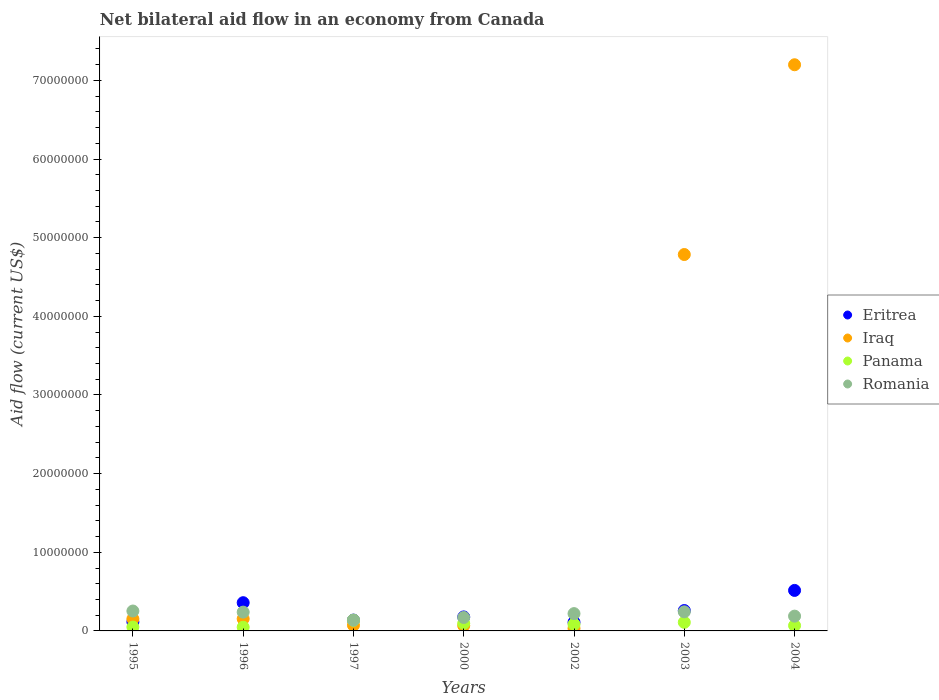What is the net bilateral aid flow in Romania in 1996?
Ensure brevity in your answer.  2.39e+06. Across all years, what is the maximum net bilateral aid flow in Eritrea?
Provide a short and direct response. 5.15e+06. In which year was the net bilateral aid flow in Eritrea minimum?
Keep it short and to the point. 2002. What is the total net bilateral aid flow in Eritrea in the graph?
Your response must be concise. 1.67e+07. What is the difference between the net bilateral aid flow in Eritrea in 2002 and that in 2003?
Give a very brief answer. -1.49e+06. What is the difference between the net bilateral aid flow in Panama in 2002 and the net bilateral aid flow in Iraq in 2003?
Your response must be concise. -4.70e+07. What is the average net bilateral aid flow in Romania per year?
Give a very brief answer. 2.07e+06. In the year 1995, what is the difference between the net bilateral aid flow in Eritrea and net bilateral aid flow in Romania?
Offer a terse response. -1.38e+06. In how many years, is the net bilateral aid flow in Iraq greater than 18000000 US$?
Make the answer very short. 2. What is the ratio of the net bilateral aid flow in Iraq in 2000 to that in 2004?
Your answer should be compact. 0.01. Is the net bilateral aid flow in Eritrea in 2002 less than that in 2003?
Give a very brief answer. Yes. Is the difference between the net bilateral aid flow in Eritrea in 1995 and 2000 greater than the difference between the net bilateral aid flow in Romania in 1995 and 2000?
Your response must be concise. No. What is the difference between the highest and the lowest net bilateral aid flow in Iraq?
Give a very brief answer. 7.17e+07. In how many years, is the net bilateral aid flow in Romania greater than the average net bilateral aid flow in Romania taken over all years?
Provide a succinct answer. 4. Is the sum of the net bilateral aid flow in Iraq in 1997 and 2004 greater than the maximum net bilateral aid flow in Romania across all years?
Offer a very short reply. Yes. Is it the case that in every year, the sum of the net bilateral aid flow in Romania and net bilateral aid flow in Panama  is greater than the sum of net bilateral aid flow in Iraq and net bilateral aid flow in Eritrea?
Give a very brief answer. No. Does the net bilateral aid flow in Romania monotonically increase over the years?
Give a very brief answer. No. How many dotlines are there?
Provide a short and direct response. 4. What is the difference between two consecutive major ticks on the Y-axis?
Ensure brevity in your answer.  1.00e+07. Are the values on the major ticks of Y-axis written in scientific E-notation?
Offer a terse response. No. Does the graph contain grids?
Give a very brief answer. No. Where does the legend appear in the graph?
Give a very brief answer. Center right. What is the title of the graph?
Offer a very short reply. Net bilateral aid flow in an economy from Canada. What is the label or title of the X-axis?
Ensure brevity in your answer.  Years. What is the label or title of the Y-axis?
Provide a succinct answer. Aid flow (current US$). What is the Aid flow (current US$) in Eritrea in 1995?
Your response must be concise. 1.15e+06. What is the Aid flow (current US$) in Iraq in 1995?
Provide a succinct answer. 1.53e+06. What is the Aid flow (current US$) in Romania in 1995?
Give a very brief answer. 2.53e+06. What is the Aid flow (current US$) in Eritrea in 1996?
Offer a terse response. 3.59e+06. What is the Aid flow (current US$) in Iraq in 1996?
Ensure brevity in your answer.  1.54e+06. What is the Aid flow (current US$) of Panama in 1996?
Make the answer very short. 4.70e+05. What is the Aid flow (current US$) in Romania in 1996?
Keep it short and to the point. 2.39e+06. What is the Aid flow (current US$) of Eritrea in 1997?
Ensure brevity in your answer.  1.38e+06. What is the Aid flow (current US$) in Iraq in 1997?
Your answer should be compact. 7.20e+05. What is the Aid flow (current US$) in Panama in 1997?
Your answer should be very brief. 1.36e+06. What is the Aid flow (current US$) in Romania in 1997?
Your response must be concise. 1.36e+06. What is the Aid flow (current US$) in Eritrea in 2000?
Offer a very short reply. 1.78e+06. What is the Aid flow (current US$) in Iraq in 2000?
Provide a short and direct response. 6.70e+05. What is the Aid flow (current US$) of Panama in 2000?
Make the answer very short. 9.60e+05. What is the Aid flow (current US$) in Romania in 2000?
Make the answer very short. 1.71e+06. What is the Aid flow (current US$) in Eritrea in 2002?
Your answer should be compact. 1.10e+06. What is the Aid flow (current US$) in Iraq in 2002?
Your answer should be compact. 3.20e+05. What is the Aid flow (current US$) in Panama in 2002?
Make the answer very short. 8.40e+05. What is the Aid flow (current US$) in Romania in 2002?
Your answer should be very brief. 2.20e+06. What is the Aid flow (current US$) in Eritrea in 2003?
Offer a terse response. 2.59e+06. What is the Aid flow (current US$) of Iraq in 2003?
Your answer should be very brief. 4.79e+07. What is the Aid flow (current US$) in Panama in 2003?
Offer a terse response. 1.09e+06. What is the Aid flow (current US$) of Romania in 2003?
Provide a short and direct response. 2.43e+06. What is the Aid flow (current US$) in Eritrea in 2004?
Offer a terse response. 5.15e+06. What is the Aid flow (current US$) of Iraq in 2004?
Offer a very short reply. 7.20e+07. What is the Aid flow (current US$) of Panama in 2004?
Give a very brief answer. 6.80e+05. What is the Aid flow (current US$) of Romania in 2004?
Offer a very short reply. 1.88e+06. Across all years, what is the maximum Aid flow (current US$) in Eritrea?
Provide a succinct answer. 5.15e+06. Across all years, what is the maximum Aid flow (current US$) in Iraq?
Offer a very short reply. 7.20e+07. Across all years, what is the maximum Aid flow (current US$) in Panama?
Make the answer very short. 1.36e+06. Across all years, what is the maximum Aid flow (current US$) in Romania?
Your response must be concise. 2.53e+06. Across all years, what is the minimum Aid flow (current US$) in Eritrea?
Keep it short and to the point. 1.10e+06. Across all years, what is the minimum Aid flow (current US$) of Iraq?
Keep it short and to the point. 3.20e+05. Across all years, what is the minimum Aid flow (current US$) in Panama?
Your answer should be compact. 4.70e+05. Across all years, what is the minimum Aid flow (current US$) of Romania?
Keep it short and to the point. 1.36e+06. What is the total Aid flow (current US$) of Eritrea in the graph?
Make the answer very short. 1.67e+07. What is the total Aid flow (current US$) in Iraq in the graph?
Offer a very short reply. 1.25e+08. What is the total Aid flow (current US$) of Panama in the graph?
Your response must be concise. 5.89e+06. What is the total Aid flow (current US$) of Romania in the graph?
Make the answer very short. 1.45e+07. What is the difference between the Aid flow (current US$) of Eritrea in 1995 and that in 1996?
Keep it short and to the point. -2.44e+06. What is the difference between the Aid flow (current US$) in Iraq in 1995 and that in 1997?
Provide a short and direct response. 8.10e+05. What is the difference between the Aid flow (current US$) of Panama in 1995 and that in 1997?
Provide a short and direct response. -8.70e+05. What is the difference between the Aid flow (current US$) in Romania in 1995 and that in 1997?
Keep it short and to the point. 1.17e+06. What is the difference between the Aid flow (current US$) in Eritrea in 1995 and that in 2000?
Give a very brief answer. -6.30e+05. What is the difference between the Aid flow (current US$) of Iraq in 1995 and that in 2000?
Make the answer very short. 8.60e+05. What is the difference between the Aid flow (current US$) in Panama in 1995 and that in 2000?
Your response must be concise. -4.70e+05. What is the difference between the Aid flow (current US$) of Romania in 1995 and that in 2000?
Give a very brief answer. 8.20e+05. What is the difference between the Aid flow (current US$) in Eritrea in 1995 and that in 2002?
Keep it short and to the point. 5.00e+04. What is the difference between the Aid flow (current US$) of Iraq in 1995 and that in 2002?
Provide a succinct answer. 1.21e+06. What is the difference between the Aid flow (current US$) of Panama in 1995 and that in 2002?
Offer a very short reply. -3.50e+05. What is the difference between the Aid flow (current US$) in Romania in 1995 and that in 2002?
Your answer should be compact. 3.30e+05. What is the difference between the Aid flow (current US$) in Eritrea in 1995 and that in 2003?
Offer a very short reply. -1.44e+06. What is the difference between the Aid flow (current US$) of Iraq in 1995 and that in 2003?
Offer a very short reply. -4.63e+07. What is the difference between the Aid flow (current US$) of Panama in 1995 and that in 2003?
Keep it short and to the point. -6.00e+05. What is the difference between the Aid flow (current US$) in Romania in 1995 and that in 2003?
Ensure brevity in your answer.  1.00e+05. What is the difference between the Aid flow (current US$) of Eritrea in 1995 and that in 2004?
Keep it short and to the point. -4.00e+06. What is the difference between the Aid flow (current US$) of Iraq in 1995 and that in 2004?
Make the answer very short. -7.05e+07. What is the difference between the Aid flow (current US$) in Panama in 1995 and that in 2004?
Your answer should be compact. -1.90e+05. What is the difference between the Aid flow (current US$) of Romania in 1995 and that in 2004?
Make the answer very short. 6.50e+05. What is the difference between the Aid flow (current US$) of Eritrea in 1996 and that in 1997?
Your answer should be very brief. 2.21e+06. What is the difference between the Aid flow (current US$) in Iraq in 1996 and that in 1997?
Your answer should be compact. 8.20e+05. What is the difference between the Aid flow (current US$) in Panama in 1996 and that in 1997?
Ensure brevity in your answer.  -8.90e+05. What is the difference between the Aid flow (current US$) of Romania in 1996 and that in 1997?
Ensure brevity in your answer.  1.03e+06. What is the difference between the Aid flow (current US$) in Eritrea in 1996 and that in 2000?
Your answer should be very brief. 1.81e+06. What is the difference between the Aid flow (current US$) of Iraq in 1996 and that in 2000?
Your answer should be compact. 8.70e+05. What is the difference between the Aid flow (current US$) of Panama in 1996 and that in 2000?
Offer a very short reply. -4.90e+05. What is the difference between the Aid flow (current US$) in Romania in 1996 and that in 2000?
Provide a short and direct response. 6.80e+05. What is the difference between the Aid flow (current US$) in Eritrea in 1996 and that in 2002?
Your answer should be compact. 2.49e+06. What is the difference between the Aid flow (current US$) of Iraq in 1996 and that in 2002?
Give a very brief answer. 1.22e+06. What is the difference between the Aid flow (current US$) in Panama in 1996 and that in 2002?
Provide a succinct answer. -3.70e+05. What is the difference between the Aid flow (current US$) of Iraq in 1996 and that in 2003?
Offer a very short reply. -4.63e+07. What is the difference between the Aid flow (current US$) in Panama in 1996 and that in 2003?
Your answer should be very brief. -6.20e+05. What is the difference between the Aid flow (current US$) in Romania in 1996 and that in 2003?
Provide a succinct answer. -4.00e+04. What is the difference between the Aid flow (current US$) in Eritrea in 1996 and that in 2004?
Offer a terse response. -1.56e+06. What is the difference between the Aid flow (current US$) in Iraq in 1996 and that in 2004?
Your answer should be compact. -7.04e+07. What is the difference between the Aid flow (current US$) in Panama in 1996 and that in 2004?
Your answer should be compact. -2.10e+05. What is the difference between the Aid flow (current US$) of Romania in 1996 and that in 2004?
Provide a short and direct response. 5.10e+05. What is the difference between the Aid flow (current US$) of Eritrea in 1997 and that in 2000?
Keep it short and to the point. -4.00e+05. What is the difference between the Aid flow (current US$) in Iraq in 1997 and that in 2000?
Keep it short and to the point. 5.00e+04. What is the difference between the Aid flow (current US$) of Romania in 1997 and that in 2000?
Provide a succinct answer. -3.50e+05. What is the difference between the Aid flow (current US$) of Panama in 1997 and that in 2002?
Provide a short and direct response. 5.20e+05. What is the difference between the Aid flow (current US$) in Romania in 1997 and that in 2002?
Ensure brevity in your answer.  -8.40e+05. What is the difference between the Aid flow (current US$) in Eritrea in 1997 and that in 2003?
Offer a very short reply. -1.21e+06. What is the difference between the Aid flow (current US$) of Iraq in 1997 and that in 2003?
Offer a very short reply. -4.71e+07. What is the difference between the Aid flow (current US$) in Romania in 1997 and that in 2003?
Give a very brief answer. -1.07e+06. What is the difference between the Aid flow (current US$) of Eritrea in 1997 and that in 2004?
Your answer should be very brief. -3.77e+06. What is the difference between the Aid flow (current US$) in Iraq in 1997 and that in 2004?
Ensure brevity in your answer.  -7.13e+07. What is the difference between the Aid flow (current US$) in Panama in 1997 and that in 2004?
Ensure brevity in your answer.  6.80e+05. What is the difference between the Aid flow (current US$) in Romania in 1997 and that in 2004?
Keep it short and to the point. -5.20e+05. What is the difference between the Aid flow (current US$) of Eritrea in 2000 and that in 2002?
Your response must be concise. 6.80e+05. What is the difference between the Aid flow (current US$) of Iraq in 2000 and that in 2002?
Give a very brief answer. 3.50e+05. What is the difference between the Aid flow (current US$) in Romania in 2000 and that in 2002?
Keep it short and to the point. -4.90e+05. What is the difference between the Aid flow (current US$) in Eritrea in 2000 and that in 2003?
Your answer should be compact. -8.10e+05. What is the difference between the Aid flow (current US$) of Iraq in 2000 and that in 2003?
Your answer should be compact. -4.72e+07. What is the difference between the Aid flow (current US$) in Romania in 2000 and that in 2003?
Provide a short and direct response. -7.20e+05. What is the difference between the Aid flow (current US$) in Eritrea in 2000 and that in 2004?
Provide a short and direct response. -3.37e+06. What is the difference between the Aid flow (current US$) of Iraq in 2000 and that in 2004?
Make the answer very short. -7.13e+07. What is the difference between the Aid flow (current US$) in Romania in 2000 and that in 2004?
Your answer should be very brief. -1.70e+05. What is the difference between the Aid flow (current US$) in Eritrea in 2002 and that in 2003?
Offer a very short reply. -1.49e+06. What is the difference between the Aid flow (current US$) in Iraq in 2002 and that in 2003?
Provide a succinct answer. -4.75e+07. What is the difference between the Aid flow (current US$) in Panama in 2002 and that in 2003?
Provide a short and direct response. -2.50e+05. What is the difference between the Aid flow (current US$) in Romania in 2002 and that in 2003?
Your answer should be compact. -2.30e+05. What is the difference between the Aid flow (current US$) of Eritrea in 2002 and that in 2004?
Provide a succinct answer. -4.05e+06. What is the difference between the Aid flow (current US$) of Iraq in 2002 and that in 2004?
Your answer should be very brief. -7.17e+07. What is the difference between the Aid flow (current US$) in Eritrea in 2003 and that in 2004?
Offer a very short reply. -2.56e+06. What is the difference between the Aid flow (current US$) of Iraq in 2003 and that in 2004?
Provide a short and direct response. -2.41e+07. What is the difference between the Aid flow (current US$) of Panama in 2003 and that in 2004?
Offer a very short reply. 4.10e+05. What is the difference between the Aid flow (current US$) in Romania in 2003 and that in 2004?
Offer a very short reply. 5.50e+05. What is the difference between the Aid flow (current US$) in Eritrea in 1995 and the Aid flow (current US$) in Iraq in 1996?
Keep it short and to the point. -3.90e+05. What is the difference between the Aid flow (current US$) in Eritrea in 1995 and the Aid flow (current US$) in Panama in 1996?
Your response must be concise. 6.80e+05. What is the difference between the Aid flow (current US$) in Eritrea in 1995 and the Aid flow (current US$) in Romania in 1996?
Offer a very short reply. -1.24e+06. What is the difference between the Aid flow (current US$) in Iraq in 1995 and the Aid flow (current US$) in Panama in 1996?
Offer a very short reply. 1.06e+06. What is the difference between the Aid flow (current US$) of Iraq in 1995 and the Aid flow (current US$) of Romania in 1996?
Your answer should be very brief. -8.60e+05. What is the difference between the Aid flow (current US$) of Panama in 1995 and the Aid flow (current US$) of Romania in 1996?
Offer a very short reply. -1.90e+06. What is the difference between the Aid flow (current US$) in Eritrea in 1995 and the Aid flow (current US$) in Panama in 1997?
Your response must be concise. -2.10e+05. What is the difference between the Aid flow (current US$) of Eritrea in 1995 and the Aid flow (current US$) of Romania in 1997?
Provide a succinct answer. -2.10e+05. What is the difference between the Aid flow (current US$) of Panama in 1995 and the Aid flow (current US$) of Romania in 1997?
Offer a terse response. -8.70e+05. What is the difference between the Aid flow (current US$) of Eritrea in 1995 and the Aid flow (current US$) of Panama in 2000?
Give a very brief answer. 1.90e+05. What is the difference between the Aid flow (current US$) of Eritrea in 1995 and the Aid flow (current US$) of Romania in 2000?
Provide a succinct answer. -5.60e+05. What is the difference between the Aid flow (current US$) in Iraq in 1995 and the Aid flow (current US$) in Panama in 2000?
Offer a very short reply. 5.70e+05. What is the difference between the Aid flow (current US$) in Panama in 1995 and the Aid flow (current US$) in Romania in 2000?
Your answer should be very brief. -1.22e+06. What is the difference between the Aid flow (current US$) of Eritrea in 1995 and the Aid flow (current US$) of Iraq in 2002?
Make the answer very short. 8.30e+05. What is the difference between the Aid flow (current US$) of Eritrea in 1995 and the Aid flow (current US$) of Romania in 2002?
Your answer should be very brief. -1.05e+06. What is the difference between the Aid flow (current US$) of Iraq in 1995 and the Aid flow (current US$) of Panama in 2002?
Offer a terse response. 6.90e+05. What is the difference between the Aid flow (current US$) of Iraq in 1995 and the Aid flow (current US$) of Romania in 2002?
Provide a succinct answer. -6.70e+05. What is the difference between the Aid flow (current US$) of Panama in 1995 and the Aid flow (current US$) of Romania in 2002?
Give a very brief answer. -1.71e+06. What is the difference between the Aid flow (current US$) of Eritrea in 1995 and the Aid flow (current US$) of Iraq in 2003?
Your answer should be very brief. -4.67e+07. What is the difference between the Aid flow (current US$) of Eritrea in 1995 and the Aid flow (current US$) of Panama in 2003?
Offer a very short reply. 6.00e+04. What is the difference between the Aid flow (current US$) of Eritrea in 1995 and the Aid flow (current US$) of Romania in 2003?
Make the answer very short. -1.28e+06. What is the difference between the Aid flow (current US$) of Iraq in 1995 and the Aid flow (current US$) of Panama in 2003?
Make the answer very short. 4.40e+05. What is the difference between the Aid flow (current US$) of Iraq in 1995 and the Aid flow (current US$) of Romania in 2003?
Make the answer very short. -9.00e+05. What is the difference between the Aid flow (current US$) in Panama in 1995 and the Aid flow (current US$) in Romania in 2003?
Offer a very short reply. -1.94e+06. What is the difference between the Aid flow (current US$) in Eritrea in 1995 and the Aid flow (current US$) in Iraq in 2004?
Keep it short and to the point. -7.08e+07. What is the difference between the Aid flow (current US$) of Eritrea in 1995 and the Aid flow (current US$) of Romania in 2004?
Provide a succinct answer. -7.30e+05. What is the difference between the Aid flow (current US$) of Iraq in 1995 and the Aid flow (current US$) of Panama in 2004?
Offer a very short reply. 8.50e+05. What is the difference between the Aid flow (current US$) in Iraq in 1995 and the Aid flow (current US$) in Romania in 2004?
Provide a succinct answer. -3.50e+05. What is the difference between the Aid flow (current US$) in Panama in 1995 and the Aid flow (current US$) in Romania in 2004?
Give a very brief answer. -1.39e+06. What is the difference between the Aid flow (current US$) of Eritrea in 1996 and the Aid flow (current US$) of Iraq in 1997?
Provide a succinct answer. 2.87e+06. What is the difference between the Aid flow (current US$) of Eritrea in 1996 and the Aid flow (current US$) of Panama in 1997?
Your response must be concise. 2.23e+06. What is the difference between the Aid flow (current US$) of Eritrea in 1996 and the Aid flow (current US$) of Romania in 1997?
Offer a very short reply. 2.23e+06. What is the difference between the Aid flow (current US$) in Panama in 1996 and the Aid flow (current US$) in Romania in 1997?
Your answer should be compact. -8.90e+05. What is the difference between the Aid flow (current US$) of Eritrea in 1996 and the Aid flow (current US$) of Iraq in 2000?
Ensure brevity in your answer.  2.92e+06. What is the difference between the Aid flow (current US$) in Eritrea in 1996 and the Aid flow (current US$) in Panama in 2000?
Give a very brief answer. 2.63e+06. What is the difference between the Aid flow (current US$) of Eritrea in 1996 and the Aid flow (current US$) of Romania in 2000?
Offer a very short reply. 1.88e+06. What is the difference between the Aid flow (current US$) of Iraq in 1996 and the Aid flow (current US$) of Panama in 2000?
Offer a very short reply. 5.80e+05. What is the difference between the Aid flow (current US$) of Iraq in 1996 and the Aid flow (current US$) of Romania in 2000?
Offer a very short reply. -1.70e+05. What is the difference between the Aid flow (current US$) in Panama in 1996 and the Aid flow (current US$) in Romania in 2000?
Your response must be concise. -1.24e+06. What is the difference between the Aid flow (current US$) in Eritrea in 1996 and the Aid flow (current US$) in Iraq in 2002?
Keep it short and to the point. 3.27e+06. What is the difference between the Aid flow (current US$) of Eritrea in 1996 and the Aid flow (current US$) of Panama in 2002?
Provide a succinct answer. 2.75e+06. What is the difference between the Aid flow (current US$) of Eritrea in 1996 and the Aid flow (current US$) of Romania in 2002?
Keep it short and to the point. 1.39e+06. What is the difference between the Aid flow (current US$) of Iraq in 1996 and the Aid flow (current US$) of Romania in 2002?
Offer a very short reply. -6.60e+05. What is the difference between the Aid flow (current US$) of Panama in 1996 and the Aid flow (current US$) of Romania in 2002?
Offer a terse response. -1.73e+06. What is the difference between the Aid flow (current US$) of Eritrea in 1996 and the Aid flow (current US$) of Iraq in 2003?
Give a very brief answer. -4.43e+07. What is the difference between the Aid flow (current US$) in Eritrea in 1996 and the Aid flow (current US$) in Panama in 2003?
Provide a short and direct response. 2.50e+06. What is the difference between the Aid flow (current US$) in Eritrea in 1996 and the Aid flow (current US$) in Romania in 2003?
Make the answer very short. 1.16e+06. What is the difference between the Aid flow (current US$) in Iraq in 1996 and the Aid flow (current US$) in Romania in 2003?
Your answer should be compact. -8.90e+05. What is the difference between the Aid flow (current US$) of Panama in 1996 and the Aid flow (current US$) of Romania in 2003?
Offer a very short reply. -1.96e+06. What is the difference between the Aid flow (current US$) in Eritrea in 1996 and the Aid flow (current US$) in Iraq in 2004?
Make the answer very short. -6.84e+07. What is the difference between the Aid flow (current US$) of Eritrea in 1996 and the Aid flow (current US$) of Panama in 2004?
Ensure brevity in your answer.  2.91e+06. What is the difference between the Aid flow (current US$) in Eritrea in 1996 and the Aid flow (current US$) in Romania in 2004?
Make the answer very short. 1.71e+06. What is the difference between the Aid flow (current US$) of Iraq in 1996 and the Aid flow (current US$) of Panama in 2004?
Your response must be concise. 8.60e+05. What is the difference between the Aid flow (current US$) in Iraq in 1996 and the Aid flow (current US$) in Romania in 2004?
Provide a short and direct response. -3.40e+05. What is the difference between the Aid flow (current US$) in Panama in 1996 and the Aid flow (current US$) in Romania in 2004?
Offer a very short reply. -1.41e+06. What is the difference between the Aid flow (current US$) of Eritrea in 1997 and the Aid flow (current US$) of Iraq in 2000?
Keep it short and to the point. 7.10e+05. What is the difference between the Aid flow (current US$) in Eritrea in 1997 and the Aid flow (current US$) in Panama in 2000?
Give a very brief answer. 4.20e+05. What is the difference between the Aid flow (current US$) in Eritrea in 1997 and the Aid flow (current US$) in Romania in 2000?
Your response must be concise. -3.30e+05. What is the difference between the Aid flow (current US$) in Iraq in 1997 and the Aid flow (current US$) in Panama in 2000?
Keep it short and to the point. -2.40e+05. What is the difference between the Aid flow (current US$) of Iraq in 1997 and the Aid flow (current US$) of Romania in 2000?
Ensure brevity in your answer.  -9.90e+05. What is the difference between the Aid flow (current US$) in Panama in 1997 and the Aid flow (current US$) in Romania in 2000?
Give a very brief answer. -3.50e+05. What is the difference between the Aid flow (current US$) of Eritrea in 1997 and the Aid flow (current US$) of Iraq in 2002?
Provide a short and direct response. 1.06e+06. What is the difference between the Aid flow (current US$) in Eritrea in 1997 and the Aid flow (current US$) in Panama in 2002?
Make the answer very short. 5.40e+05. What is the difference between the Aid flow (current US$) of Eritrea in 1997 and the Aid flow (current US$) of Romania in 2002?
Your answer should be very brief. -8.20e+05. What is the difference between the Aid flow (current US$) in Iraq in 1997 and the Aid flow (current US$) in Panama in 2002?
Give a very brief answer. -1.20e+05. What is the difference between the Aid flow (current US$) in Iraq in 1997 and the Aid flow (current US$) in Romania in 2002?
Ensure brevity in your answer.  -1.48e+06. What is the difference between the Aid flow (current US$) in Panama in 1997 and the Aid flow (current US$) in Romania in 2002?
Provide a short and direct response. -8.40e+05. What is the difference between the Aid flow (current US$) in Eritrea in 1997 and the Aid flow (current US$) in Iraq in 2003?
Make the answer very short. -4.65e+07. What is the difference between the Aid flow (current US$) in Eritrea in 1997 and the Aid flow (current US$) in Romania in 2003?
Ensure brevity in your answer.  -1.05e+06. What is the difference between the Aid flow (current US$) of Iraq in 1997 and the Aid flow (current US$) of Panama in 2003?
Your answer should be compact. -3.70e+05. What is the difference between the Aid flow (current US$) of Iraq in 1997 and the Aid flow (current US$) of Romania in 2003?
Make the answer very short. -1.71e+06. What is the difference between the Aid flow (current US$) of Panama in 1997 and the Aid flow (current US$) of Romania in 2003?
Offer a very short reply. -1.07e+06. What is the difference between the Aid flow (current US$) in Eritrea in 1997 and the Aid flow (current US$) in Iraq in 2004?
Make the answer very short. -7.06e+07. What is the difference between the Aid flow (current US$) of Eritrea in 1997 and the Aid flow (current US$) of Panama in 2004?
Give a very brief answer. 7.00e+05. What is the difference between the Aid flow (current US$) of Eritrea in 1997 and the Aid flow (current US$) of Romania in 2004?
Provide a succinct answer. -5.00e+05. What is the difference between the Aid flow (current US$) in Iraq in 1997 and the Aid flow (current US$) in Panama in 2004?
Provide a short and direct response. 4.00e+04. What is the difference between the Aid flow (current US$) of Iraq in 1997 and the Aid flow (current US$) of Romania in 2004?
Your answer should be very brief. -1.16e+06. What is the difference between the Aid flow (current US$) of Panama in 1997 and the Aid flow (current US$) of Romania in 2004?
Make the answer very short. -5.20e+05. What is the difference between the Aid flow (current US$) in Eritrea in 2000 and the Aid flow (current US$) in Iraq in 2002?
Give a very brief answer. 1.46e+06. What is the difference between the Aid flow (current US$) in Eritrea in 2000 and the Aid flow (current US$) in Panama in 2002?
Offer a terse response. 9.40e+05. What is the difference between the Aid flow (current US$) in Eritrea in 2000 and the Aid flow (current US$) in Romania in 2002?
Keep it short and to the point. -4.20e+05. What is the difference between the Aid flow (current US$) in Iraq in 2000 and the Aid flow (current US$) in Romania in 2002?
Your response must be concise. -1.53e+06. What is the difference between the Aid flow (current US$) in Panama in 2000 and the Aid flow (current US$) in Romania in 2002?
Your answer should be compact. -1.24e+06. What is the difference between the Aid flow (current US$) in Eritrea in 2000 and the Aid flow (current US$) in Iraq in 2003?
Keep it short and to the point. -4.61e+07. What is the difference between the Aid flow (current US$) of Eritrea in 2000 and the Aid flow (current US$) of Panama in 2003?
Make the answer very short. 6.90e+05. What is the difference between the Aid flow (current US$) in Eritrea in 2000 and the Aid flow (current US$) in Romania in 2003?
Make the answer very short. -6.50e+05. What is the difference between the Aid flow (current US$) of Iraq in 2000 and the Aid flow (current US$) of Panama in 2003?
Provide a short and direct response. -4.20e+05. What is the difference between the Aid flow (current US$) in Iraq in 2000 and the Aid flow (current US$) in Romania in 2003?
Offer a very short reply. -1.76e+06. What is the difference between the Aid flow (current US$) in Panama in 2000 and the Aid flow (current US$) in Romania in 2003?
Your answer should be compact. -1.47e+06. What is the difference between the Aid flow (current US$) in Eritrea in 2000 and the Aid flow (current US$) in Iraq in 2004?
Provide a short and direct response. -7.02e+07. What is the difference between the Aid flow (current US$) in Eritrea in 2000 and the Aid flow (current US$) in Panama in 2004?
Provide a succinct answer. 1.10e+06. What is the difference between the Aid flow (current US$) in Eritrea in 2000 and the Aid flow (current US$) in Romania in 2004?
Offer a terse response. -1.00e+05. What is the difference between the Aid flow (current US$) of Iraq in 2000 and the Aid flow (current US$) of Panama in 2004?
Keep it short and to the point. -10000. What is the difference between the Aid flow (current US$) of Iraq in 2000 and the Aid flow (current US$) of Romania in 2004?
Give a very brief answer. -1.21e+06. What is the difference between the Aid flow (current US$) in Panama in 2000 and the Aid flow (current US$) in Romania in 2004?
Your response must be concise. -9.20e+05. What is the difference between the Aid flow (current US$) in Eritrea in 2002 and the Aid flow (current US$) in Iraq in 2003?
Your answer should be very brief. -4.68e+07. What is the difference between the Aid flow (current US$) of Eritrea in 2002 and the Aid flow (current US$) of Panama in 2003?
Keep it short and to the point. 10000. What is the difference between the Aid flow (current US$) in Eritrea in 2002 and the Aid flow (current US$) in Romania in 2003?
Ensure brevity in your answer.  -1.33e+06. What is the difference between the Aid flow (current US$) of Iraq in 2002 and the Aid flow (current US$) of Panama in 2003?
Ensure brevity in your answer.  -7.70e+05. What is the difference between the Aid flow (current US$) in Iraq in 2002 and the Aid flow (current US$) in Romania in 2003?
Give a very brief answer. -2.11e+06. What is the difference between the Aid flow (current US$) of Panama in 2002 and the Aid flow (current US$) of Romania in 2003?
Your answer should be compact. -1.59e+06. What is the difference between the Aid flow (current US$) in Eritrea in 2002 and the Aid flow (current US$) in Iraq in 2004?
Offer a very short reply. -7.09e+07. What is the difference between the Aid flow (current US$) in Eritrea in 2002 and the Aid flow (current US$) in Romania in 2004?
Your answer should be compact. -7.80e+05. What is the difference between the Aid flow (current US$) of Iraq in 2002 and the Aid flow (current US$) of Panama in 2004?
Ensure brevity in your answer.  -3.60e+05. What is the difference between the Aid flow (current US$) of Iraq in 2002 and the Aid flow (current US$) of Romania in 2004?
Your answer should be compact. -1.56e+06. What is the difference between the Aid flow (current US$) in Panama in 2002 and the Aid flow (current US$) in Romania in 2004?
Provide a succinct answer. -1.04e+06. What is the difference between the Aid flow (current US$) in Eritrea in 2003 and the Aid flow (current US$) in Iraq in 2004?
Offer a terse response. -6.94e+07. What is the difference between the Aid flow (current US$) in Eritrea in 2003 and the Aid flow (current US$) in Panama in 2004?
Your response must be concise. 1.91e+06. What is the difference between the Aid flow (current US$) of Eritrea in 2003 and the Aid flow (current US$) of Romania in 2004?
Provide a short and direct response. 7.10e+05. What is the difference between the Aid flow (current US$) of Iraq in 2003 and the Aid flow (current US$) of Panama in 2004?
Keep it short and to the point. 4.72e+07. What is the difference between the Aid flow (current US$) of Iraq in 2003 and the Aid flow (current US$) of Romania in 2004?
Your answer should be compact. 4.60e+07. What is the difference between the Aid flow (current US$) in Panama in 2003 and the Aid flow (current US$) in Romania in 2004?
Your answer should be compact. -7.90e+05. What is the average Aid flow (current US$) in Eritrea per year?
Your answer should be compact. 2.39e+06. What is the average Aid flow (current US$) of Iraq per year?
Offer a very short reply. 1.78e+07. What is the average Aid flow (current US$) of Panama per year?
Provide a short and direct response. 8.41e+05. What is the average Aid flow (current US$) of Romania per year?
Your response must be concise. 2.07e+06. In the year 1995, what is the difference between the Aid flow (current US$) of Eritrea and Aid flow (current US$) of Iraq?
Your response must be concise. -3.80e+05. In the year 1995, what is the difference between the Aid flow (current US$) in Eritrea and Aid flow (current US$) in Romania?
Ensure brevity in your answer.  -1.38e+06. In the year 1995, what is the difference between the Aid flow (current US$) of Iraq and Aid flow (current US$) of Panama?
Make the answer very short. 1.04e+06. In the year 1995, what is the difference between the Aid flow (current US$) of Iraq and Aid flow (current US$) of Romania?
Your response must be concise. -1.00e+06. In the year 1995, what is the difference between the Aid flow (current US$) in Panama and Aid flow (current US$) in Romania?
Give a very brief answer. -2.04e+06. In the year 1996, what is the difference between the Aid flow (current US$) in Eritrea and Aid flow (current US$) in Iraq?
Offer a very short reply. 2.05e+06. In the year 1996, what is the difference between the Aid flow (current US$) in Eritrea and Aid flow (current US$) in Panama?
Your answer should be very brief. 3.12e+06. In the year 1996, what is the difference between the Aid flow (current US$) in Eritrea and Aid flow (current US$) in Romania?
Keep it short and to the point. 1.20e+06. In the year 1996, what is the difference between the Aid flow (current US$) of Iraq and Aid flow (current US$) of Panama?
Your answer should be very brief. 1.07e+06. In the year 1996, what is the difference between the Aid flow (current US$) of Iraq and Aid flow (current US$) of Romania?
Your answer should be very brief. -8.50e+05. In the year 1996, what is the difference between the Aid flow (current US$) of Panama and Aid flow (current US$) of Romania?
Keep it short and to the point. -1.92e+06. In the year 1997, what is the difference between the Aid flow (current US$) of Eritrea and Aid flow (current US$) of Iraq?
Your answer should be very brief. 6.60e+05. In the year 1997, what is the difference between the Aid flow (current US$) of Eritrea and Aid flow (current US$) of Panama?
Provide a succinct answer. 2.00e+04. In the year 1997, what is the difference between the Aid flow (current US$) of Eritrea and Aid flow (current US$) of Romania?
Provide a succinct answer. 2.00e+04. In the year 1997, what is the difference between the Aid flow (current US$) in Iraq and Aid flow (current US$) in Panama?
Offer a very short reply. -6.40e+05. In the year 1997, what is the difference between the Aid flow (current US$) of Iraq and Aid flow (current US$) of Romania?
Give a very brief answer. -6.40e+05. In the year 2000, what is the difference between the Aid flow (current US$) of Eritrea and Aid flow (current US$) of Iraq?
Offer a very short reply. 1.11e+06. In the year 2000, what is the difference between the Aid flow (current US$) of Eritrea and Aid flow (current US$) of Panama?
Ensure brevity in your answer.  8.20e+05. In the year 2000, what is the difference between the Aid flow (current US$) of Eritrea and Aid flow (current US$) of Romania?
Provide a short and direct response. 7.00e+04. In the year 2000, what is the difference between the Aid flow (current US$) in Iraq and Aid flow (current US$) in Romania?
Your answer should be compact. -1.04e+06. In the year 2000, what is the difference between the Aid flow (current US$) of Panama and Aid flow (current US$) of Romania?
Give a very brief answer. -7.50e+05. In the year 2002, what is the difference between the Aid flow (current US$) in Eritrea and Aid flow (current US$) in Iraq?
Offer a very short reply. 7.80e+05. In the year 2002, what is the difference between the Aid flow (current US$) of Eritrea and Aid flow (current US$) of Romania?
Ensure brevity in your answer.  -1.10e+06. In the year 2002, what is the difference between the Aid flow (current US$) in Iraq and Aid flow (current US$) in Panama?
Your answer should be very brief. -5.20e+05. In the year 2002, what is the difference between the Aid flow (current US$) of Iraq and Aid flow (current US$) of Romania?
Provide a short and direct response. -1.88e+06. In the year 2002, what is the difference between the Aid flow (current US$) of Panama and Aid flow (current US$) of Romania?
Ensure brevity in your answer.  -1.36e+06. In the year 2003, what is the difference between the Aid flow (current US$) of Eritrea and Aid flow (current US$) of Iraq?
Your response must be concise. -4.53e+07. In the year 2003, what is the difference between the Aid flow (current US$) of Eritrea and Aid flow (current US$) of Panama?
Give a very brief answer. 1.50e+06. In the year 2003, what is the difference between the Aid flow (current US$) in Eritrea and Aid flow (current US$) in Romania?
Your answer should be compact. 1.60e+05. In the year 2003, what is the difference between the Aid flow (current US$) of Iraq and Aid flow (current US$) of Panama?
Ensure brevity in your answer.  4.68e+07. In the year 2003, what is the difference between the Aid flow (current US$) in Iraq and Aid flow (current US$) in Romania?
Offer a very short reply. 4.54e+07. In the year 2003, what is the difference between the Aid flow (current US$) in Panama and Aid flow (current US$) in Romania?
Your response must be concise. -1.34e+06. In the year 2004, what is the difference between the Aid flow (current US$) of Eritrea and Aid flow (current US$) of Iraq?
Provide a succinct answer. -6.68e+07. In the year 2004, what is the difference between the Aid flow (current US$) in Eritrea and Aid flow (current US$) in Panama?
Your response must be concise. 4.47e+06. In the year 2004, what is the difference between the Aid flow (current US$) of Eritrea and Aid flow (current US$) of Romania?
Give a very brief answer. 3.27e+06. In the year 2004, what is the difference between the Aid flow (current US$) in Iraq and Aid flow (current US$) in Panama?
Offer a terse response. 7.13e+07. In the year 2004, what is the difference between the Aid flow (current US$) of Iraq and Aid flow (current US$) of Romania?
Give a very brief answer. 7.01e+07. In the year 2004, what is the difference between the Aid flow (current US$) of Panama and Aid flow (current US$) of Romania?
Make the answer very short. -1.20e+06. What is the ratio of the Aid flow (current US$) in Eritrea in 1995 to that in 1996?
Offer a very short reply. 0.32. What is the ratio of the Aid flow (current US$) of Iraq in 1995 to that in 1996?
Your answer should be compact. 0.99. What is the ratio of the Aid flow (current US$) of Panama in 1995 to that in 1996?
Keep it short and to the point. 1.04. What is the ratio of the Aid flow (current US$) of Romania in 1995 to that in 1996?
Your response must be concise. 1.06. What is the ratio of the Aid flow (current US$) in Iraq in 1995 to that in 1997?
Provide a short and direct response. 2.12. What is the ratio of the Aid flow (current US$) of Panama in 1995 to that in 1997?
Offer a very short reply. 0.36. What is the ratio of the Aid flow (current US$) in Romania in 1995 to that in 1997?
Offer a terse response. 1.86. What is the ratio of the Aid flow (current US$) in Eritrea in 1995 to that in 2000?
Ensure brevity in your answer.  0.65. What is the ratio of the Aid flow (current US$) of Iraq in 1995 to that in 2000?
Give a very brief answer. 2.28. What is the ratio of the Aid flow (current US$) of Panama in 1995 to that in 2000?
Provide a succinct answer. 0.51. What is the ratio of the Aid flow (current US$) in Romania in 1995 to that in 2000?
Your answer should be very brief. 1.48. What is the ratio of the Aid flow (current US$) of Eritrea in 1995 to that in 2002?
Ensure brevity in your answer.  1.05. What is the ratio of the Aid flow (current US$) of Iraq in 1995 to that in 2002?
Offer a terse response. 4.78. What is the ratio of the Aid flow (current US$) in Panama in 1995 to that in 2002?
Provide a succinct answer. 0.58. What is the ratio of the Aid flow (current US$) of Romania in 1995 to that in 2002?
Your response must be concise. 1.15. What is the ratio of the Aid flow (current US$) in Eritrea in 1995 to that in 2003?
Keep it short and to the point. 0.44. What is the ratio of the Aid flow (current US$) in Iraq in 1995 to that in 2003?
Give a very brief answer. 0.03. What is the ratio of the Aid flow (current US$) of Panama in 1995 to that in 2003?
Your answer should be very brief. 0.45. What is the ratio of the Aid flow (current US$) in Romania in 1995 to that in 2003?
Make the answer very short. 1.04. What is the ratio of the Aid flow (current US$) of Eritrea in 1995 to that in 2004?
Your response must be concise. 0.22. What is the ratio of the Aid flow (current US$) in Iraq in 1995 to that in 2004?
Provide a succinct answer. 0.02. What is the ratio of the Aid flow (current US$) of Panama in 1995 to that in 2004?
Offer a very short reply. 0.72. What is the ratio of the Aid flow (current US$) of Romania in 1995 to that in 2004?
Your answer should be compact. 1.35. What is the ratio of the Aid flow (current US$) in Eritrea in 1996 to that in 1997?
Ensure brevity in your answer.  2.6. What is the ratio of the Aid flow (current US$) in Iraq in 1996 to that in 1997?
Your answer should be compact. 2.14. What is the ratio of the Aid flow (current US$) of Panama in 1996 to that in 1997?
Your answer should be very brief. 0.35. What is the ratio of the Aid flow (current US$) in Romania in 1996 to that in 1997?
Your answer should be very brief. 1.76. What is the ratio of the Aid flow (current US$) in Eritrea in 1996 to that in 2000?
Your answer should be very brief. 2.02. What is the ratio of the Aid flow (current US$) of Iraq in 1996 to that in 2000?
Keep it short and to the point. 2.3. What is the ratio of the Aid flow (current US$) in Panama in 1996 to that in 2000?
Your answer should be compact. 0.49. What is the ratio of the Aid flow (current US$) in Romania in 1996 to that in 2000?
Your response must be concise. 1.4. What is the ratio of the Aid flow (current US$) of Eritrea in 1996 to that in 2002?
Ensure brevity in your answer.  3.26. What is the ratio of the Aid flow (current US$) in Iraq in 1996 to that in 2002?
Your answer should be compact. 4.81. What is the ratio of the Aid flow (current US$) of Panama in 1996 to that in 2002?
Ensure brevity in your answer.  0.56. What is the ratio of the Aid flow (current US$) in Romania in 1996 to that in 2002?
Make the answer very short. 1.09. What is the ratio of the Aid flow (current US$) of Eritrea in 1996 to that in 2003?
Provide a succinct answer. 1.39. What is the ratio of the Aid flow (current US$) of Iraq in 1996 to that in 2003?
Your answer should be compact. 0.03. What is the ratio of the Aid flow (current US$) of Panama in 1996 to that in 2003?
Provide a short and direct response. 0.43. What is the ratio of the Aid flow (current US$) of Romania in 1996 to that in 2003?
Provide a short and direct response. 0.98. What is the ratio of the Aid flow (current US$) of Eritrea in 1996 to that in 2004?
Offer a very short reply. 0.7. What is the ratio of the Aid flow (current US$) of Iraq in 1996 to that in 2004?
Keep it short and to the point. 0.02. What is the ratio of the Aid flow (current US$) in Panama in 1996 to that in 2004?
Give a very brief answer. 0.69. What is the ratio of the Aid flow (current US$) of Romania in 1996 to that in 2004?
Provide a short and direct response. 1.27. What is the ratio of the Aid flow (current US$) in Eritrea in 1997 to that in 2000?
Ensure brevity in your answer.  0.78. What is the ratio of the Aid flow (current US$) in Iraq in 1997 to that in 2000?
Your answer should be compact. 1.07. What is the ratio of the Aid flow (current US$) of Panama in 1997 to that in 2000?
Your answer should be very brief. 1.42. What is the ratio of the Aid flow (current US$) in Romania in 1997 to that in 2000?
Your answer should be very brief. 0.8. What is the ratio of the Aid flow (current US$) in Eritrea in 1997 to that in 2002?
Ensure brevity in your answer.  1.25. What is the ratio of the Aid flow (current US$) in Iraq in 1997 to that in 2002?
Your answer should be compact. 2.25. What is the ratio of the Aid flow (current US$) of Panama in 1997 to that in 2002?
Keep it short and to the point. 1.62. What is the ratio of the Aid flow (current US$) in Romania in 1997 to that in 2002?
Your answer should be very brief. 0.62. What is the ratio of the Aid flow (current US$) in Eritrea in 1997 to that in 2003?
Provide a succinct answer. 0.53. What is the ratio of the Aid flow (current US$) in Iraq in 1997 to that in 2003?
Offer a terse response. 0.01. What is the ratio of the Aid flow (current US$) of Panama in 1997 to that in 2003?
Offer a terse response. 1.25. What is the ratio of the Aid flow (current US$) in Romania in 1997 to that in 2003?
Provide a short and direct response. 0.56. What is the ratio of the Aid flow (current US$) of Eritrea in 1997 to that in 2004?
Offer a very short reply. 0.27. What is the ratio of the Aid flow (current US$) of Iraq in 1997 to that in 2004?
Provide a short and direct response. 0.01. What is the ratio of the Aid flow (current US$) of Romania in 1997 to that in 2004?
Offer a very short reply. 0.72. What is the ratio of the Aid flow (current US$) of Eritrea in 2000 to that in 2002?
Your answer should be compact. 1.62. What is the ratio of the Aid flow (current US$) of Iraq in 2000 to that in 2002?
Your response must be concise. 2.09. What is the ratio of the Aid flow (current US$) of Romania in 2000 to that in 2002?
Offer a terse response. 0.78. What is the ratio of the Aid flow (current US$) of Eritrea in 2000 to that in 2003?
Offer a very short reply. 0.69. What is the ratio of the Aid flow (current US$) of Iraq in 2000 to that in 2003?
Offer a terse response. 0.01. What is the ratio of the Aid flow (current US$) in Panama in 2000 to that in 2003?
Provide a succinct answer. 0.88. What is the ratio of the Aid flow (current US$) of Romania in 2000 to that in 2003?
Provide a short and direct response. 0.7. What is the ratio of the Aid flow (current US$) in Eritrea in 2000 to that in 2004?
Provide a succinct answer. 0.35. What is the ratio of the Aid flow (current US$) of Iraq in 2000 to that in 2004?
Offer a terse response. 0.01. What is the ratio of the Aid flow (current US$) in Panama in 2000 to that in 2004?
Your answer should be very brief. 1.41. What is the ratio of the Aid flow (current US$) of Romania in 2000 to that in 2004?
Offer a terse response. 0.91. What is the ratio of the Aid flow (current US$) in Eritrea in 2002 to that in 2003?
Offer a terse response. 0.42. What is the ratio of the Aid flow (current US$) in Iraq in 2002 to that in 2003?
Your response must be concise. 0.01. What is the ratio of the Aid flow (current US$) in Panama in 2002 to that in 2003?
Your answer should be very brief. 0.77. What is the ratio of the Aid flow (current US$) in Romania in 2002 to that in 2003?
Your response must be concise. 0.91. What is the ratio of the Aid flow (current US$) of Eritrea in 2002 to that in 2004?
Your answer should be very brief. 0.21. What is the ratio of the Aid flow (current US$) in Iraq in 2002 to that in 2004?
Keep it short and to the point. 0. What is the ratio of the Aid flow (current US$) of Panama in 2002 to that in 2004?
Give a very brief answer. 1.24. What is the ratio of the Aid flow (current US$) in Romania in 2002 to that in 2004?
Your answer should be very brief. 1.17. What is the ratio of the Aid flow (current US$) in Eritrea in 2003 to that in 2004?
Provide a succinct answer. 0.5. What is the ratio of the Aid flow (current US$) in Iraq in 2003 to that in 2004?
Give a very brief answer. 0.66. What is the ratio of the Aid flow (current US$) of Panama in 2003 to that in 2004?
Give a very brief answer. 1.6. What is the ratio of the Aid flow (current US$) of Romania in 2003 to that in 2004?
Offer a terse response. 1.29. What is the difference between the highest and the second highest Aid flow (current US$) of Eritrea?
Provide a succinct answer. 1.56e+06. What is the difference between the highest and the second highest Aid flow (current US$) of Iraq?
Provide a short and direct response. 2.41e+07. What is the difference between the highest and the lowest Aid flow (current US$) of Eritrea?
Give a very brief answer. 4.05e+06. What is the difference between the highest and the lowest Aid flow (current US$) in Iraq?
Your answer should be very brief. 7.17e+07. What is the difference between the highest and the lowest Aid flow (current US$) in Panama?
Your answer should be very brief. 8.90e+05. What is the difference between the highest and the lowest Aid flow (current US$) in Romania?
Offer a terse response. 1.17e+06. 